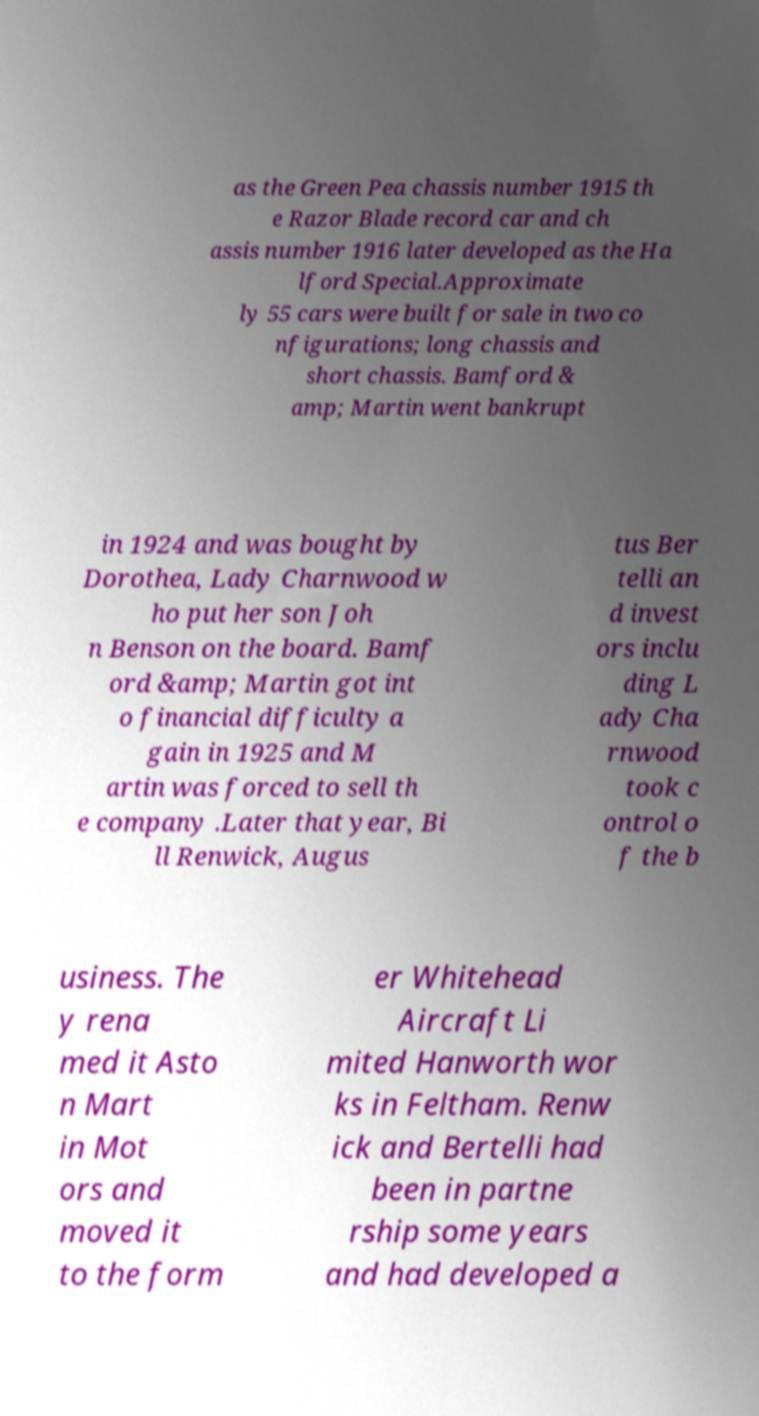Please read and relay the text visible in this image. What does it say? as the Green Pea chassis number 1915 th e Razor Blade record car and ch assis number 1916 later developed as the Ha lford Special.Approximate ly 55 cars were built for sale in two co nfigurations; long chassis and short chassis. Bamford & amp; Martin went bankrupt in 1924 and was bought by Dorothea, Lady Charnwood w ho put her son Joh n Benson on the board. Bamf ord &amp; Martin got int o financial difficulty a gain in 1925 and M artin was forced to sell th e company .Later that year, Bi ll Renwick, Augus tus Ber telli an d invest ors inclu ding L ady Cha rnwood took c ontrol o f the b usiness. The y rena med it Asto n Mart in Mot ors and moved it to the form er Whitehead Aircraft Li mited Hanworth wor ks in Feltham. Renw ick and Bertelli had been in partne rship some years and had developed a 